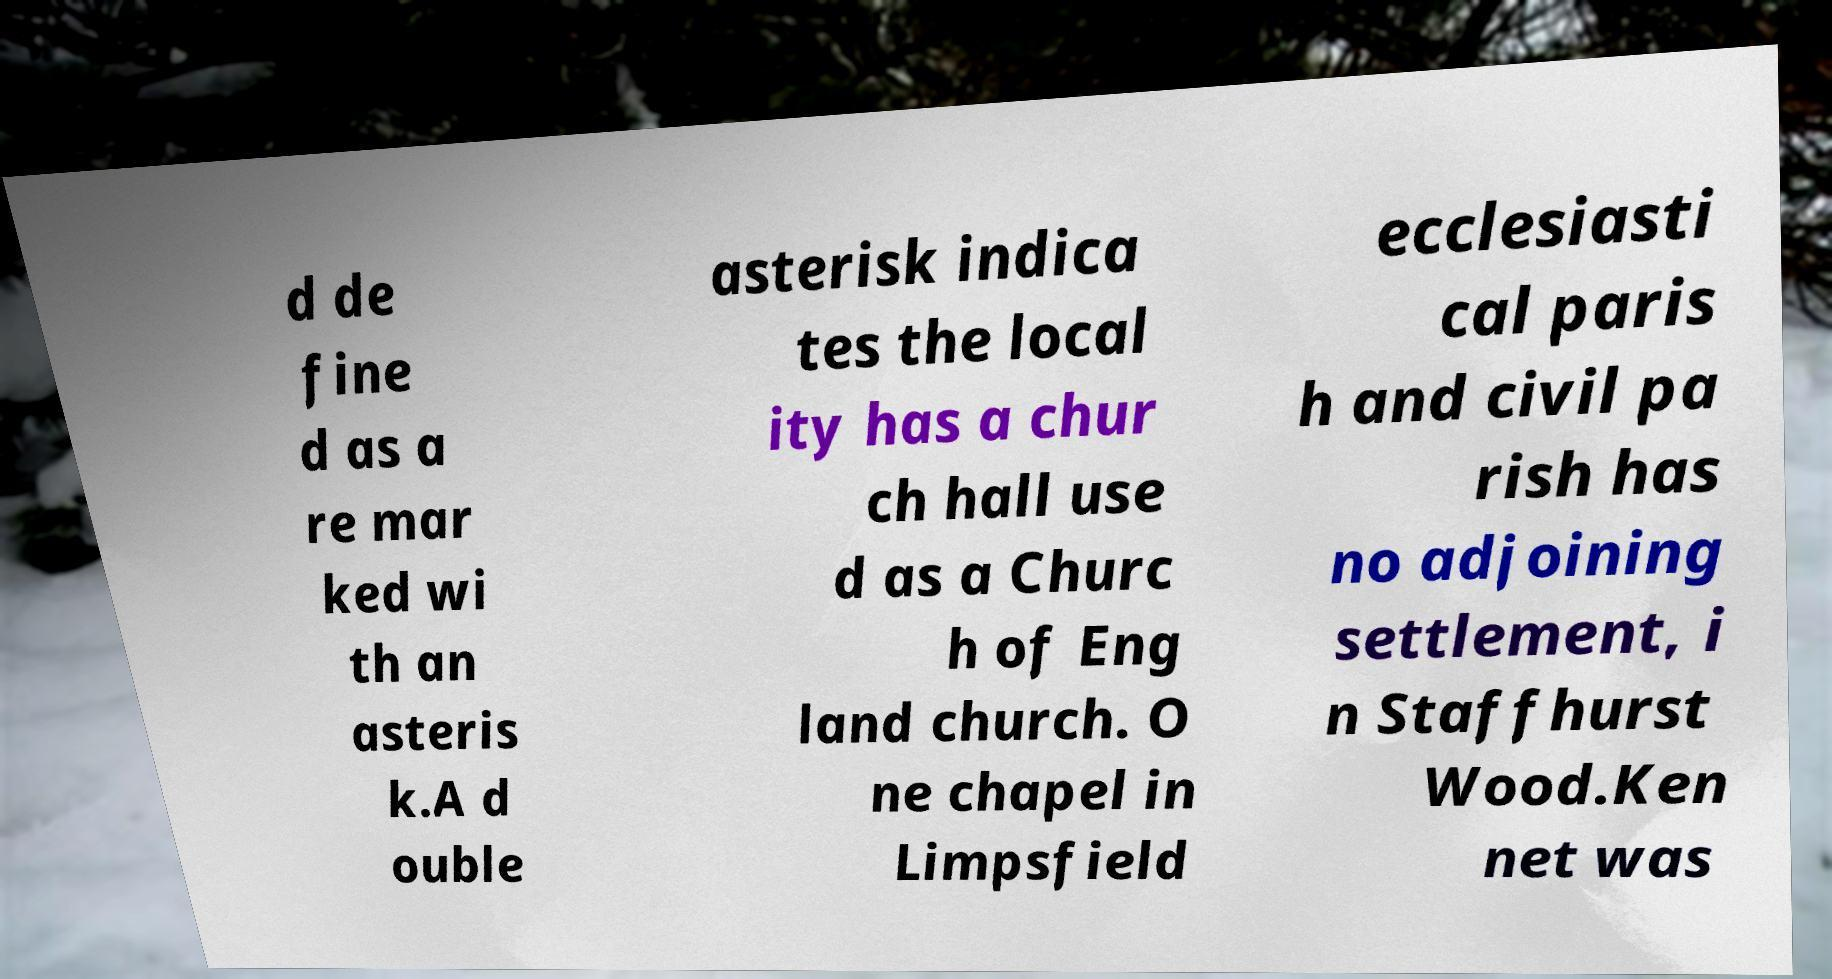What messages or text are displayed in this image? I need them in a readable, typed format. d de fine d as a re mar ked wi th an asteris k.A d ouble asterisk indica tes the local ity has a chur ch hall use d as a Churc h of Eng land church. O ne chapel in Limpsfield ecclesiasti cal paris h and civil pa rish has no adjoining settlement, i n Staffhurst Wood.Ken net was 